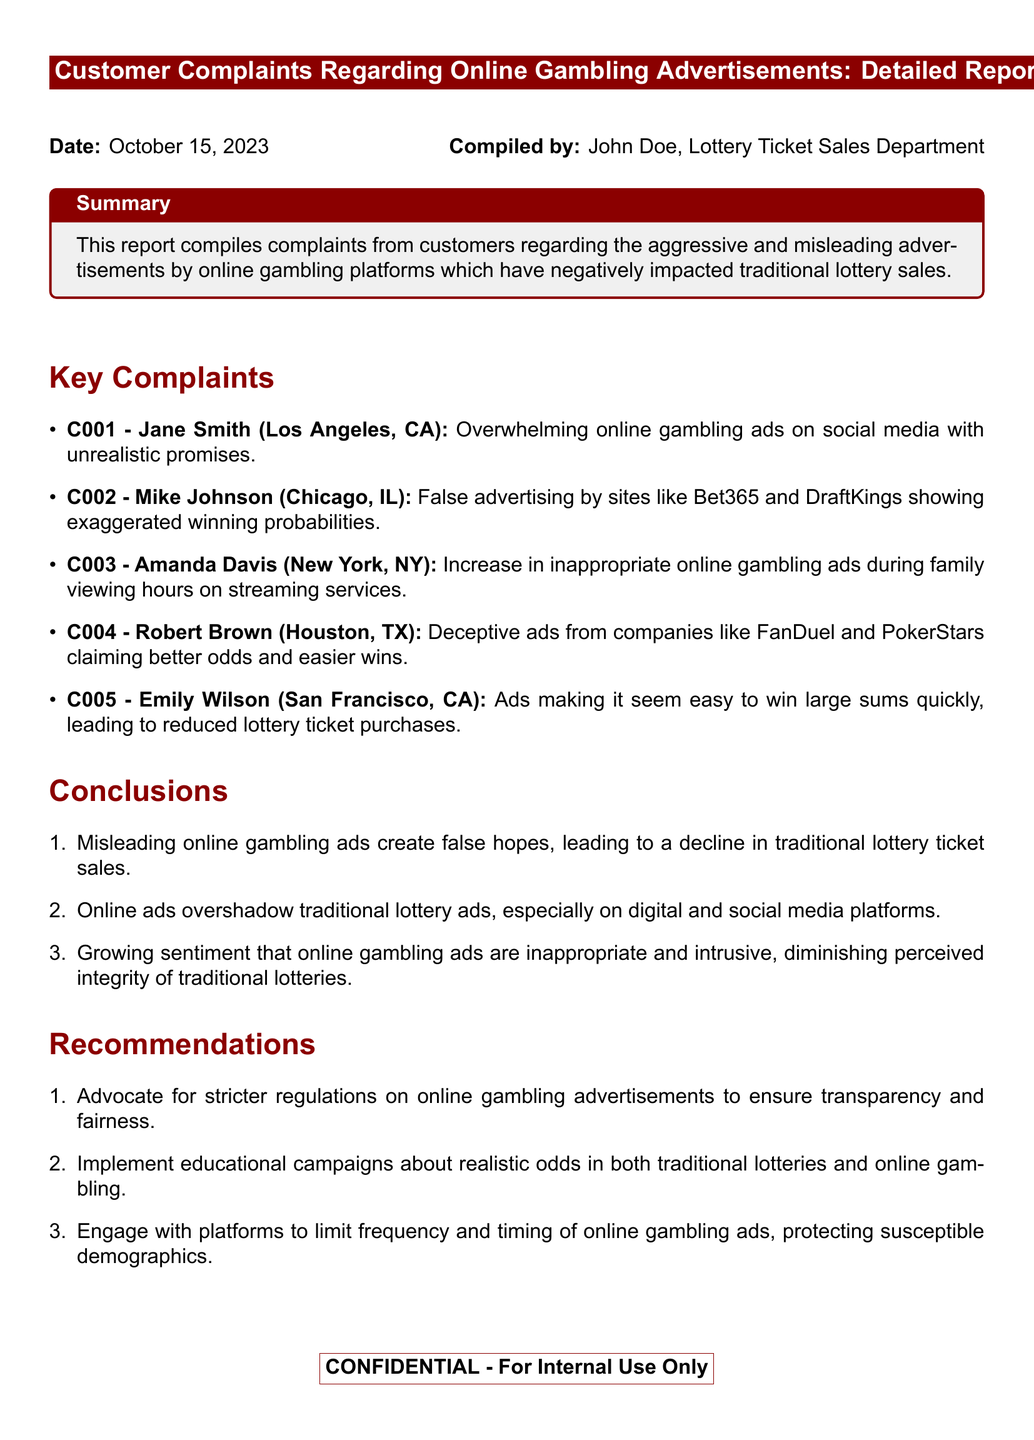What is the date of the report? The date of the report is clearly stated in the document's header.
Answer: October 15, 2023 Who compiled the report? The report includes a line identifying the person who compiled the document.
Answer: John Doe How many customer complaints are listed? The number of complaints can be counted from the "Key Complaints" section.
Answer: 5 What is the complaint code for Amanda Davis? Each complaint is assigned a unique code which can be found next to the complainant's name.
Answer: C003 What is one conclusion drawn in the report? The conclusions are listed in the "Conclusions" section and can be summarized.
Answer: Misleading online gambling ads create false hopes, leading to a decline in traditional lottery ticket sales What is one recommendation made in the report? Recommendations provided are listed in the "Recommendations" section of the document.
Answer: Advocate for stricter regulations on online gambling advertisements to ensure transparency and fairness Which city's complaints mention false advertising? The specific city mentioned in the document related to false advertising can be found in the corresponding complaint.
Answer: Chicago, IL What is a common theme among the complaints? The document indicates themes through the nature of the complaints listed, showing their commonality.
Answer: Misleading advertisements 